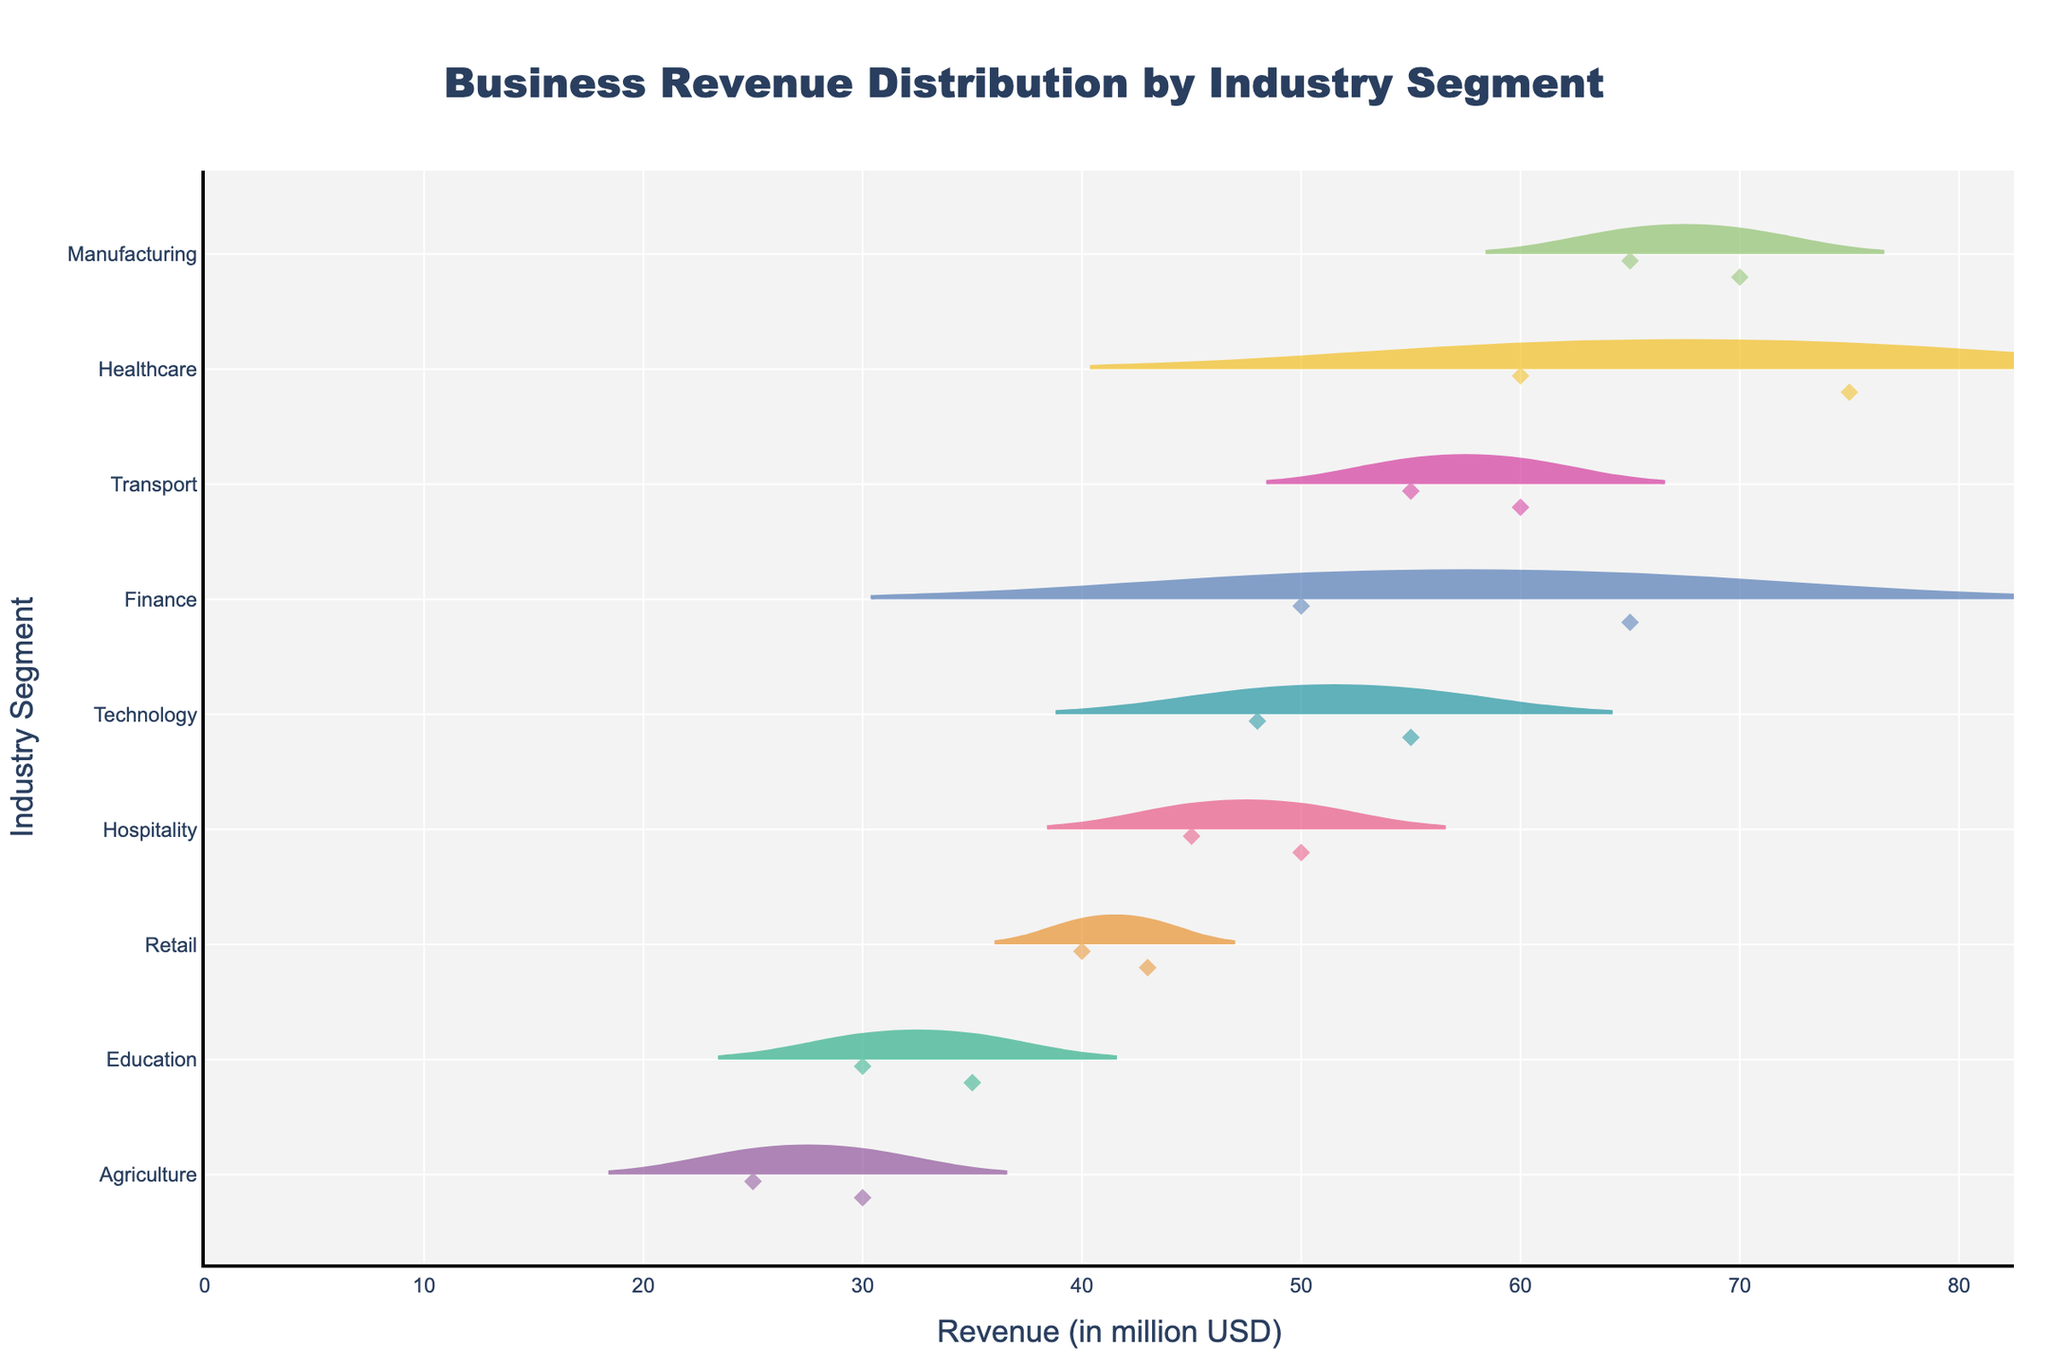What's the title of the figure? The title of the figure is located at the top and is visually distinct due to its larger font size.
Answer: 'Business Revenue Distribution by Industry Segment' Which industry aggregate has the highest revenue median? The highest revenue median can be identified by comparing the horizontal line indicating the median value within each violin plot. The Healthcare segment has the highest median since its median line is closest to the highest revenue values.
Answer: Healthcare How many data points are there in the Retail segment? The Retail segment has two data points, visible as diamond-shaped markers on the violin plot for the Retail industry.
Answer: 2 Which industry has the widest range of revenue distributions? Observing the length of the violin plots, which represents the distribution of revenues, shows that Healthcare has the widest range since its violin extends from around 60 to 75 million USD.
Answer: Healthcare What is the revenue range for the Finance industry? The Finance segment's violin plot ranges from 50 million USD to 65 million USD, indicating the revenue range.
Answer: 15 million USD Is the average revenue of Technology higher or lower than the average revenue of Manufacturing? By estimating the central tendency of the violin plots for Technology and Manufacturing, we can see that Manufacturing appears higher since Technology ranges from 48 to 55 (with an average of 51.5), while Manufacturing ranges from 65 to 70 (with an average of 67.5).
Answer: Lower Compare the median revenue of the Hospitality and Transport segments. Which one is greater? The median line for Transport is higher than that for Hospitality, indicating that Transport has a greater median revenue.
Answer: Transport What's the total revenue of the Agriculture segment? The sum total of data points for Agriculture involves adding 25 and 30, resulting in a total revenue of 55 million USD.
Answer: 55 million USD Which industry segment has the lowest revenue point? The violin plot showing the lowest revenue value is the Agriculture segment, which has a point at 25 million USD.
Answer: Agriculture How many industries have at least one company with greater than 50 million USD in revenue? By examining the individual data points within the violin plots, we observe that Technology, Healthcare, Finance, Manufacturing, Hospitality, and Transport segments all have at least one company with revenue greater than 50 million USD, totaling to six industries.
Answer: 6 